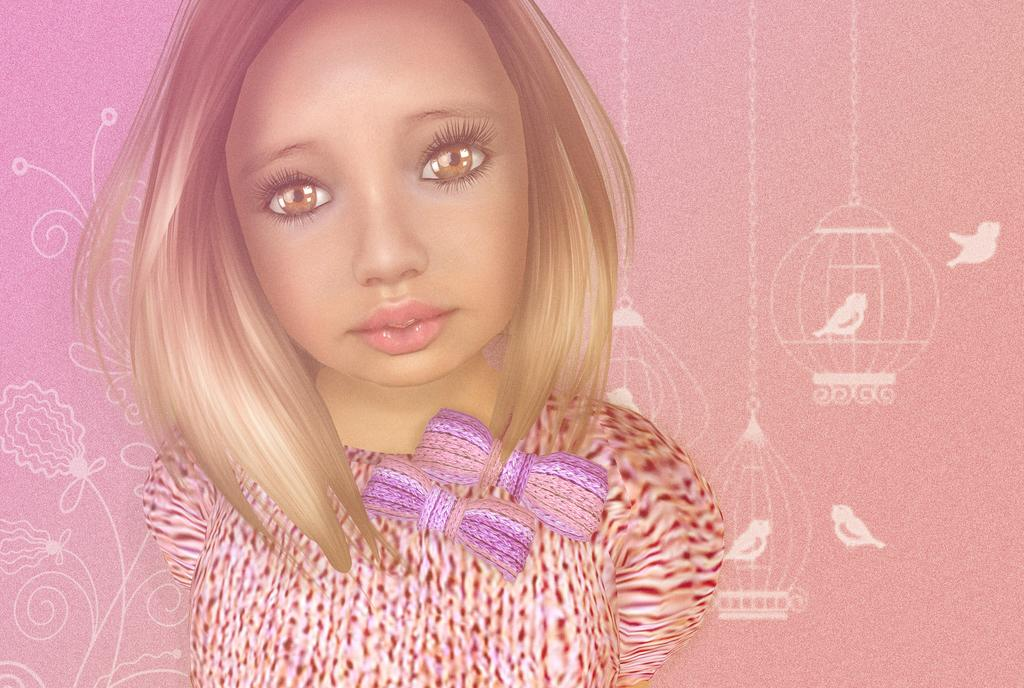Who is the main subject in the image? There is a girl in the middle of the image. What can be seen in the background of the image? There are paintings on the wall in the background of the image. What type of media is the image? The image is an animation. What type of rabbit can be seen playing with a word in the image? There is no rabbit or word present in the image; it features a girl and paintings on the wall. 